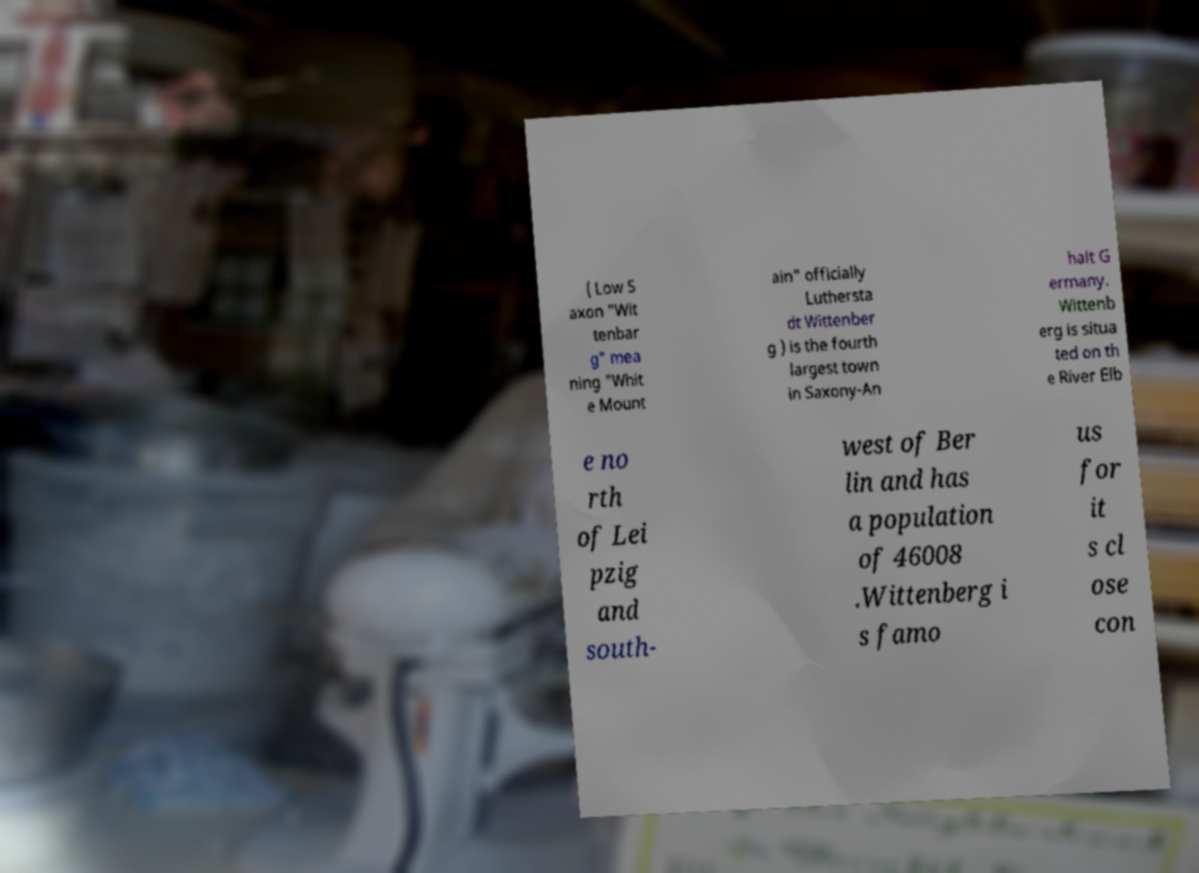Can you read and provide the text displayed in the image?This photo seems to have some interesting text. Can you extract and type it out for me? ( Low S axon "Wit tenbar g" mea ning "Whit e Mount ain" officially Luthersta dt Wittenber g ) is the fourth largest town in Saxony-An halt G ermany. Wittenb erg is situa ted on th e River Elb e no rth of Lei pzig and south- west of Ber lin and has a population of 46008 .Wittenberg i s famo us for it s cl ose con 